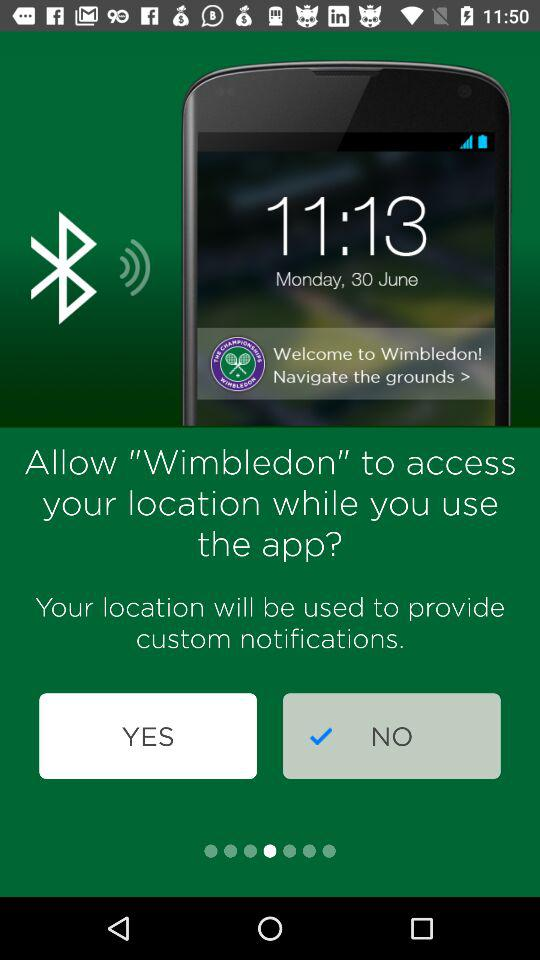What is the mentioned time? The mentioned time is 11:13. 